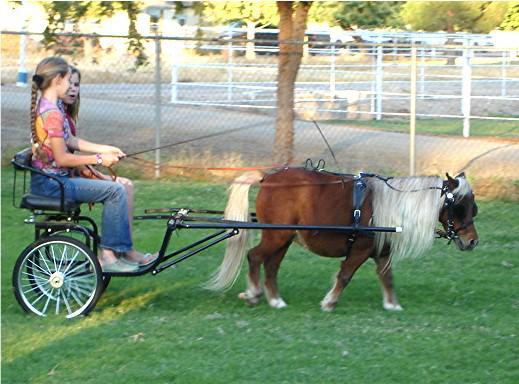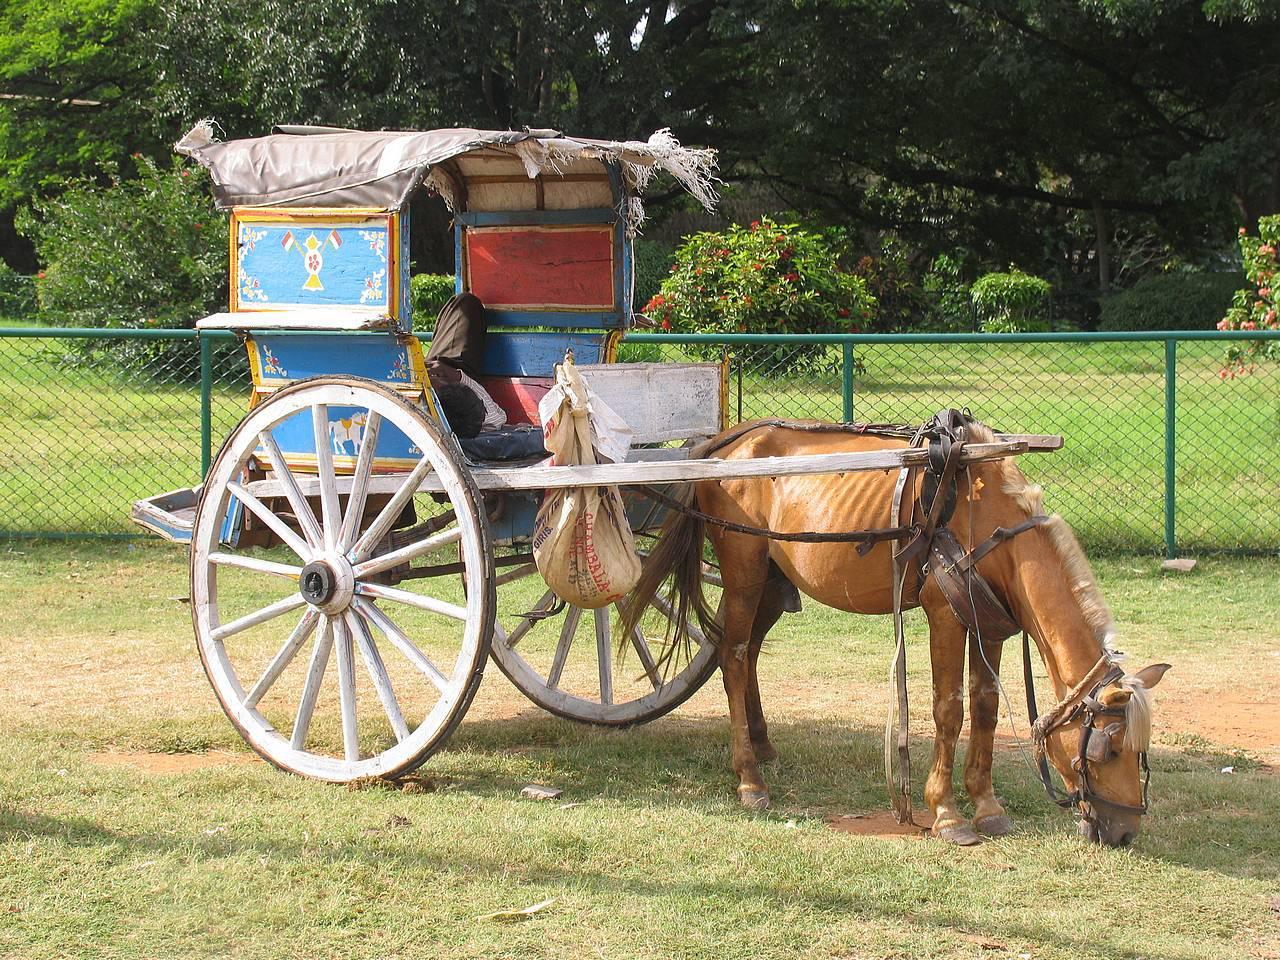The first image is the image on the left, the second image is the image on the right. Evaluate the accuracy of this statement regarding the images: "At least one horse is black.". Is it true? Answer yes or no. No. 